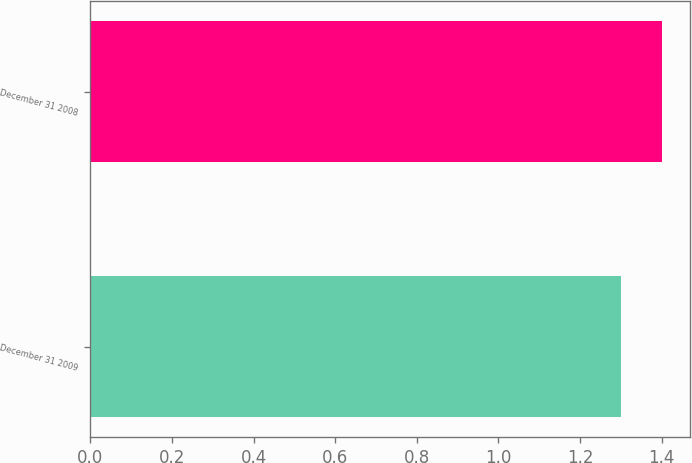Convert chart to OTSL. <chart><loc_0><loc_0><loc_500><loc_500><bar_chart><fcel>December 31 2009<fcel>December 31 2008<nl><fcel>1.3<fcel>1.4<nl></chart> 